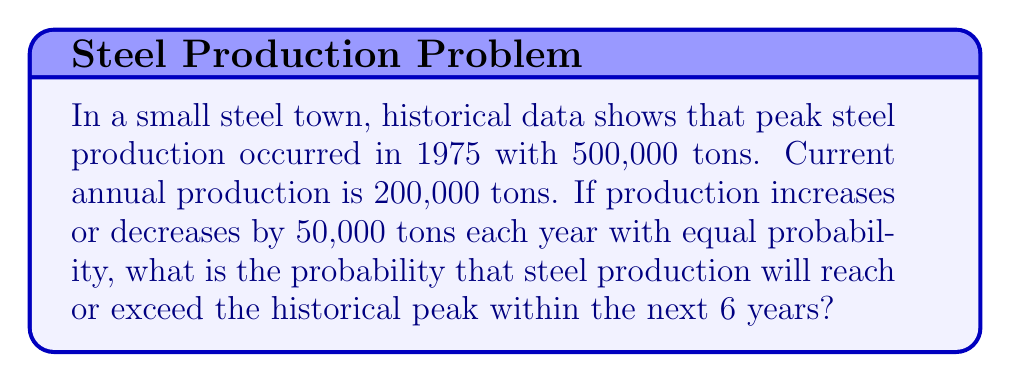Can you solve this math problem? Let's approach this step-by-step:

1) First, we need to calculate how many increases of 50,000 tons are needed to reach the historical peak:

   $\frac{500,000 - 200,000}{50,000} = 6$

2) So, we need at least 6 increases in 6 years to reach or exceed the peak.

3) This is equivalent to getting at least 6 heads in 6 coin flips, as each year has an equal probability of increase or decrease.

4) The probability of exactly 6 increases in 6 years is:

   $P(6) = \binom{6}{6} \cdot (0.5)^6 = 1 \cdot (0.5)^6 = \frac{1}{64}$

5) Therefore, the probability of reaching or exceeding the peak is just this probability.

6) We can verify this using the binomial probability formula:

   $$P(X \geq 6) = \sum_{k=6}^{6} \binom{6}{k} \cdot (0.5)^k \cdot (0.5)^{6-k} = \binom{6}{6} \cdot (0.5)^6 = \frac{1}{64}$$
Answer: $\frac{1}{64}$ 